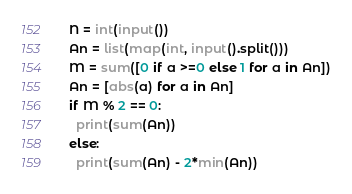Convert code to text. <code><loc_0><loc_0><loc_500><loc_500><_Python_>N = int(input())
An = list(map(int, input().split()))
M = sum([0 if a >=0 else 1 for a in An])
An = [abs(a) for a in An]
if M % 2 == 0:
  print(sum(An))
else:
  print(sum(An) - 2*min(An))
</code> 